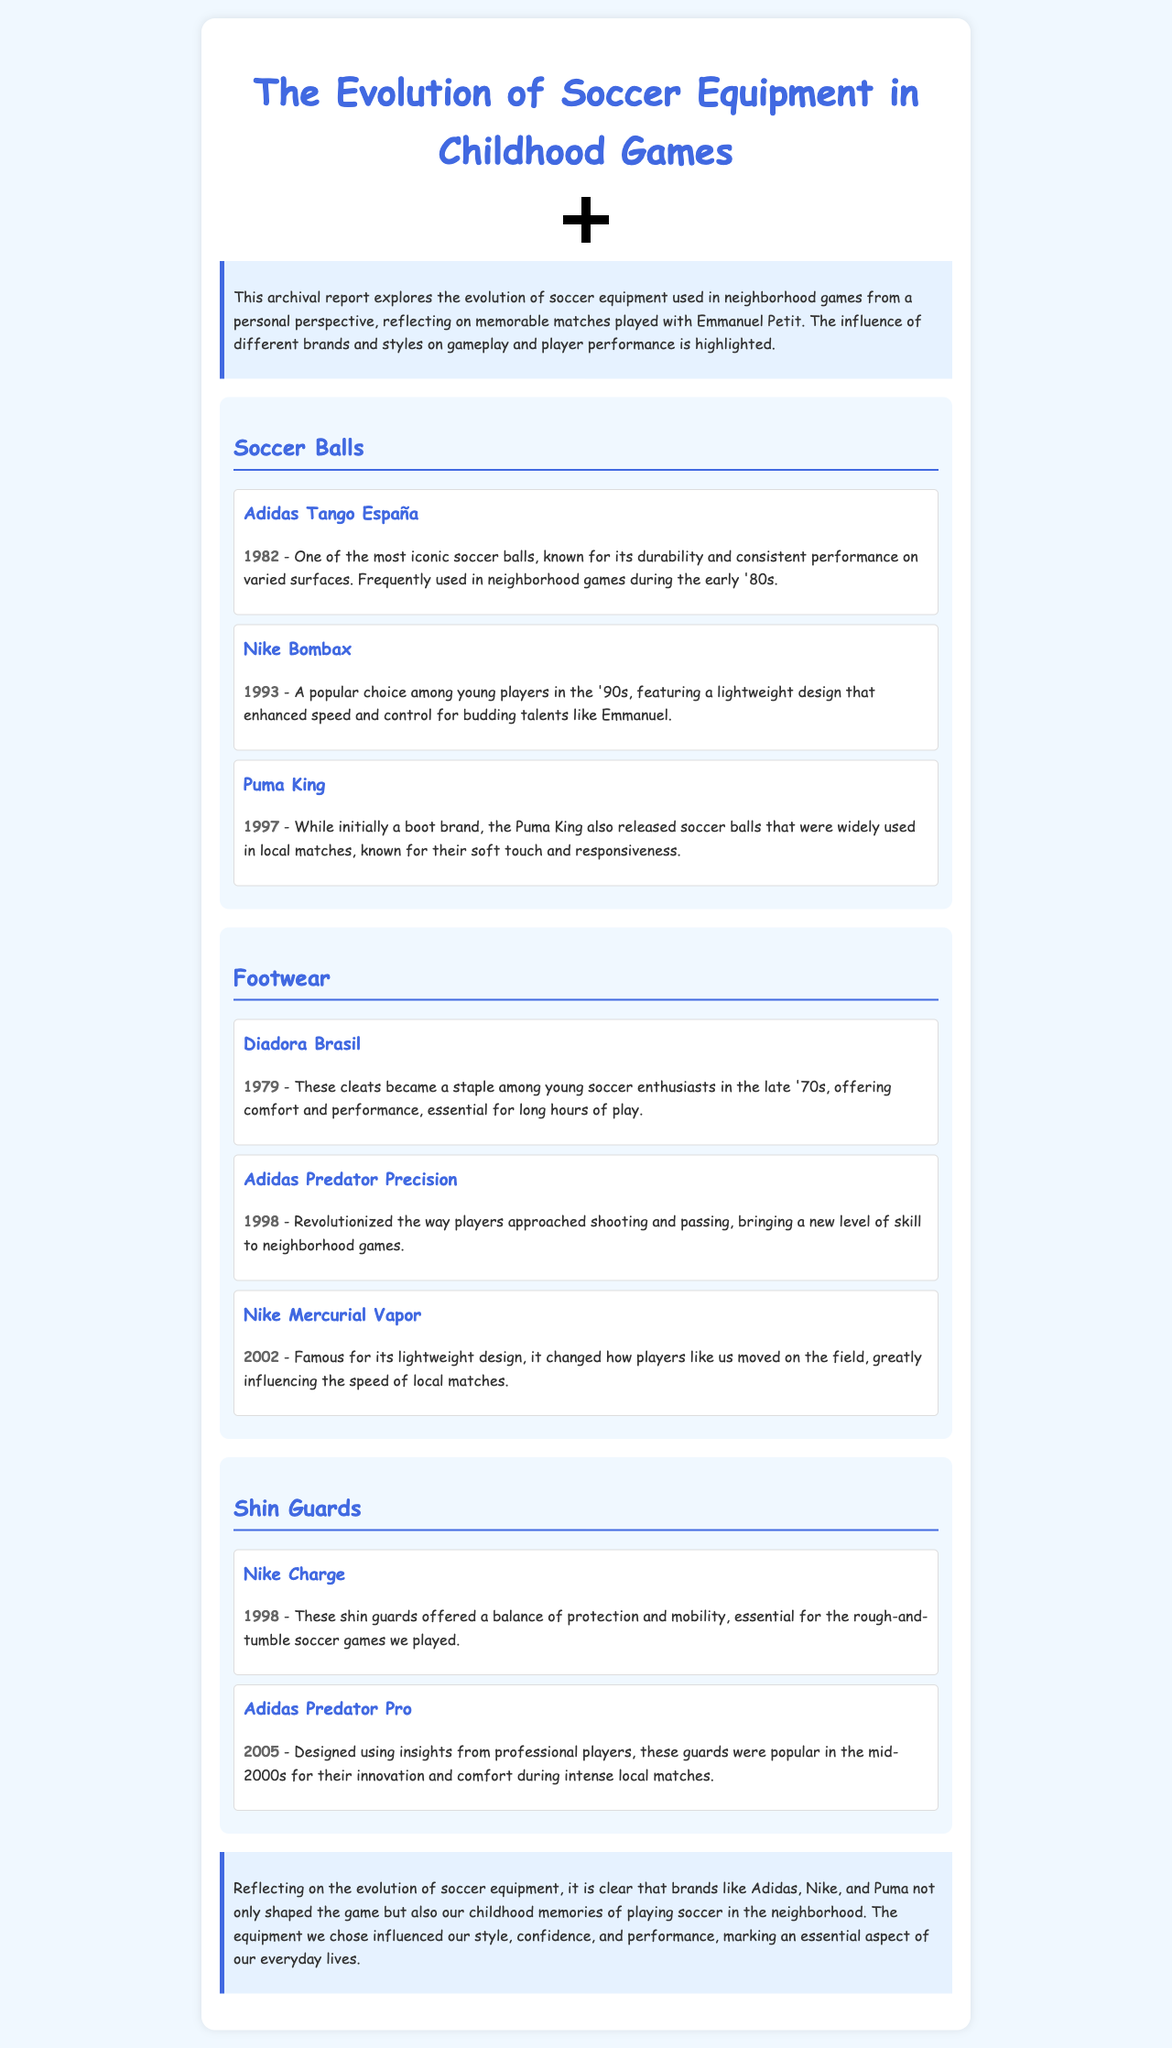What year was the Adidas Tango España released? The Adidas Tango España was released in 1982, as mentioned in the section about Soccer Balls.
Answer: 1982 Which brand introduced the lightweight Nike Bombax? The report states that the Nike Bombax was a popular choice among young players in the ‘90s, highlighting its design.
Answer: Nike What is notable about the Adidas Predator Precision? The Adidas Predator Precision revolutionized shooting and passing, which is noted in the Footwear section.
Answer: Revolutionized shooting and passing In what year were the Nike Charge shin guards introduced? The Nike Charge shin guards were introduced in 1998, as indicated in the section on Shin Guards.
Answer: 1998 How did Puma King impact local matches? The Puma King soccer balls were known for their soft touch and responsiveness, influencing gameplay in local matches.
Answer: Soft touch and responsiveness What aspect of soccer equipment does the conclusion emphasize? The conclusion emphasizes that brands shaped the game and childhood memories of playing soccer in the neighborhood.
Answer: Shaped the game and memories Which soccer ball brand was frequently used in the early '80s? The Adidas Tango España is identified as one of the most iconic soccer balls used frequently in the early '80s.
Answer: Adidas Tango España What feature did the Nike Mercurial Vapor change in gameplay? The Nike Mercurial Vapor changed the speed of local matches, essential for how players moved on the field.
Answer: Speed of local matches Which equipment type was designed considering professional players’ insights? The Adidas Predator Pro shin guards were designed based on insights from professional players, as mentioned in the report.
Answer: Shin Guards 